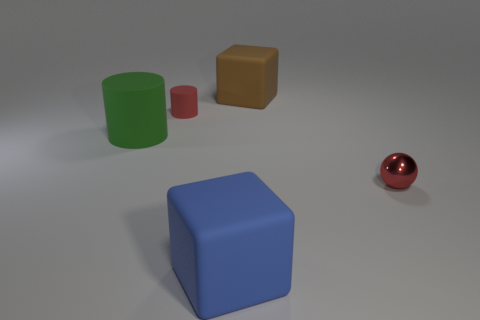Are there any other things that have the same shape as the small shiny thing?
Provide a short and direct response. No. Are there fewer small red objects to the right of the ball than cyan metal cubes?
Offer a very short reply. No. There is a small object that is behind the large green cylinder; is it the same color as the metal thing?
Keep it short and to the point. Yes. How many shiny objects are either tiny yellow spheres or tiny red spheres?
Give a very brief answer. 1. Is there anything else that is the same size as the green cylinder?
Your answer should be very brief. Yes. There is another small thing that is made of the same material as the green object; what color is it?
Provide a succinct answer. Red. What number of blocks are big brown matte objects or blue matte things?
Keep it short and to the point. 2. How many objects are either metallic balls or rubber things behind the tiny sphere?
Offer a very short reply. 4. Is there a big cyan thing?
Offer a very short reply. No. What number of small shiny spheres have the same color as the big rubber cylinder?
Offer a terse response. 0. 